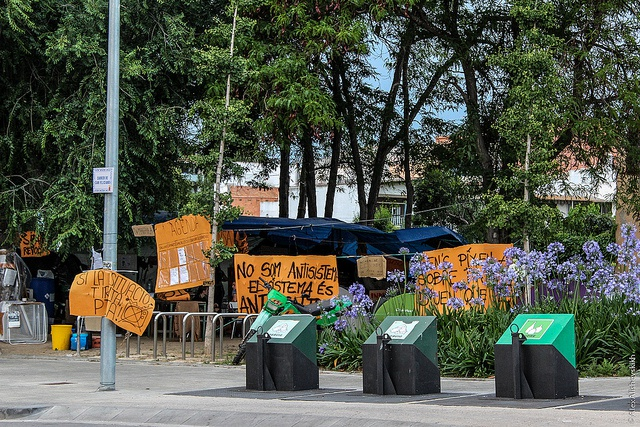Describe the objects in this image and their specific colors. I can see a motorcycle in black, gray, lightblue, and green tones in this image. 